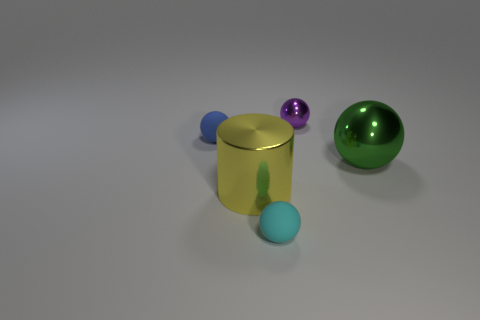Add 5 tiny purple things. How many objects exist? 10 Subtract all cylinders. How many objects are left? 4 Subtract 0 cyan blocks. How many objects are left? 5 Subtract all tiny blue blocks. Subtract all cyan balls. How many objects are left? 4 Add 4 cyan spheres. How many cyan spheres are left? 5 Add 5 small purple metallic objects. How many small purple metallic objects exist? 6 